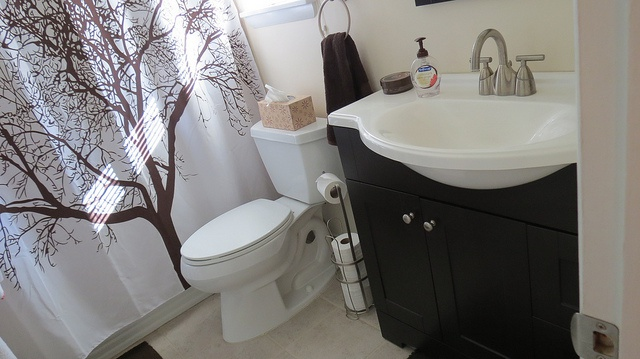Describe the objects in this image and their specific colors. I can see toilet in darkgray, gray, and lightgray tones, sink in darkgray, gray, and lightgray tones, and bottle in darkgray, gray, and black tones in this image. 